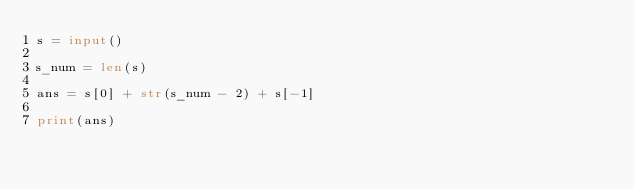<code> <loc_0><loc_0><loc_500><loc_500><_Python_>s = input()

s_num = len(s)

ans = s[0] + str(s_num - 2) + s[-1]

print(ans)</code> 